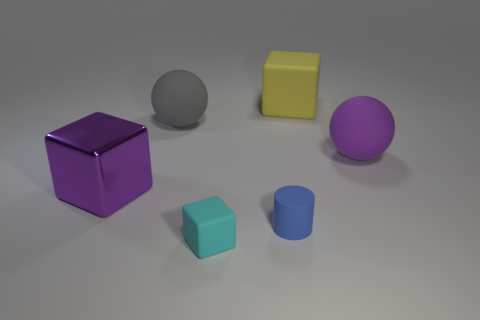Is there any other thing that is the same color as the big shiny thing?
Your answer should be compact. Yes. How many other objects are there of the same size as the cyan cube?
Offer a terse response. 1. There is a big block that is behind the large purple thing on the left side of the matte ball that is on the right side of the small block; what is it made of?
Give a very brief answer. Rubber. Do the yellow thing and the big sphere in front of the large gray object have the same material?
Make the answer very short. Yes. Is the number of yellow matte blocks on the left side of the tiny cube less than the number of big yellow rubber things on the left side of the yellow object?
Provide a succinct answer. No. What number of cyan things are the same material as the yellow cube?
Your response must be concise. 1. Is there a tiny rubber block behind the large rubber object that is left of the rubber block that is behind the rubber cylinder?
Your response must be concise. No. How many cylinders are either big cyan matte objects or blue rubber objects?
Your answer should be very brief. 1. Does the purple metallic thing have the same shape as the yellow matte thing that is to the right of the tiny cyan cube?
Keep it short and to the point. Yes. Is the number of big metal cubes right of the big purple rubber ball less than the number of tiny matte cylinders?
Offer a terse response. Yes. 